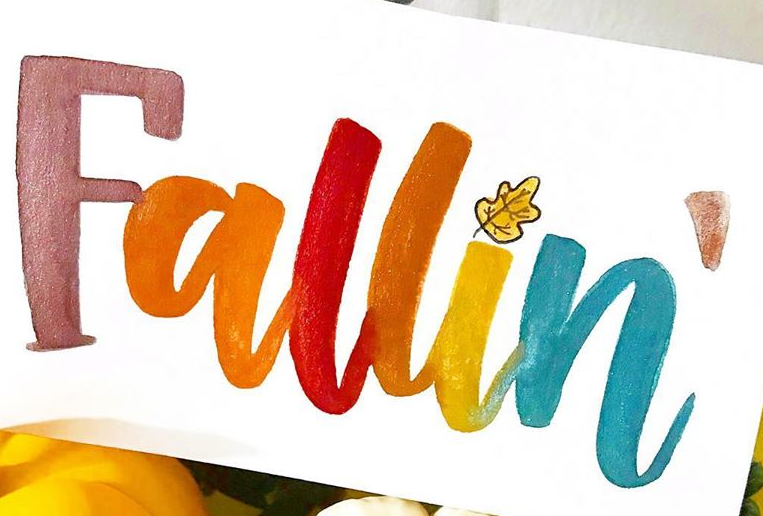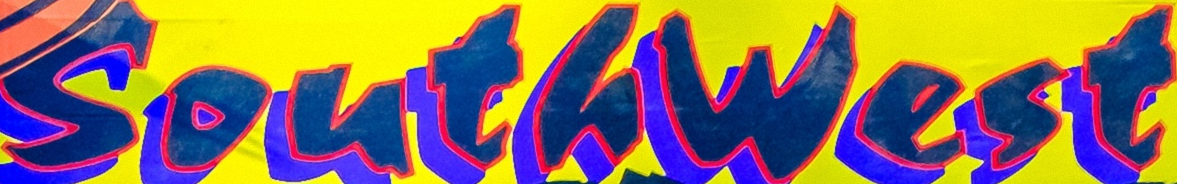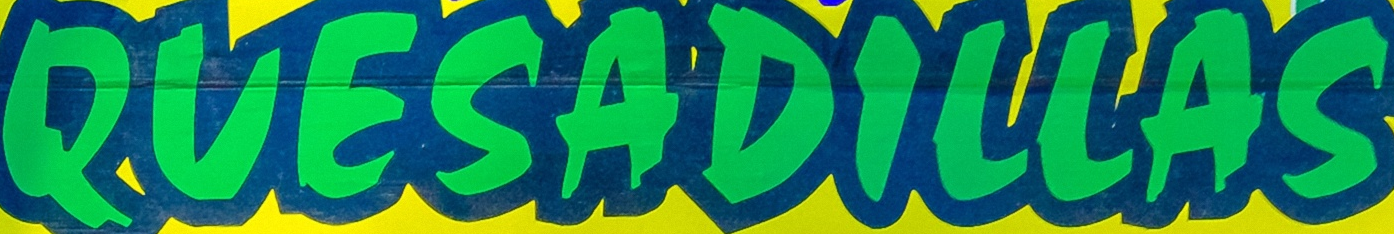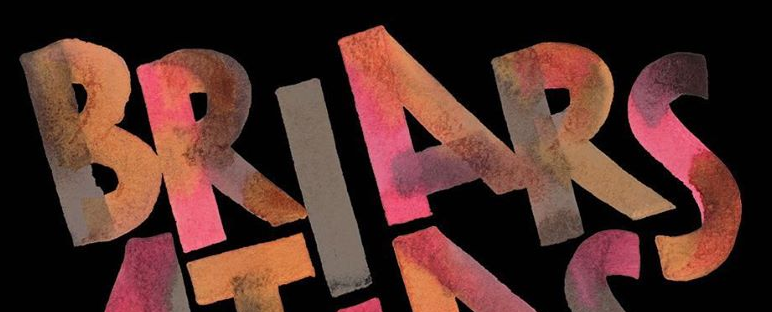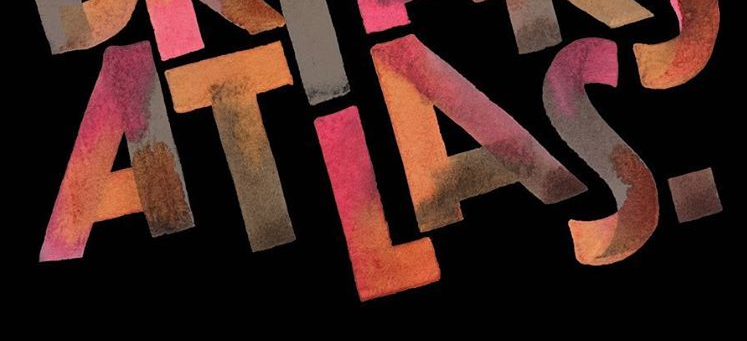Transcribe the words shown in these images in order, separated by a semicolon. Fallin; Southwest; QUESADILLAS; BRIARS; ATLAS. 